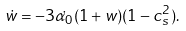<formula> <loc_0><loc_0><loc_500><loc_500>\dot { w } = - 3 \dot { \alpha _ { 0 } } ( 1 + w ) ( 1 - c _ { s } ^ { 2 } ) .</formula> 